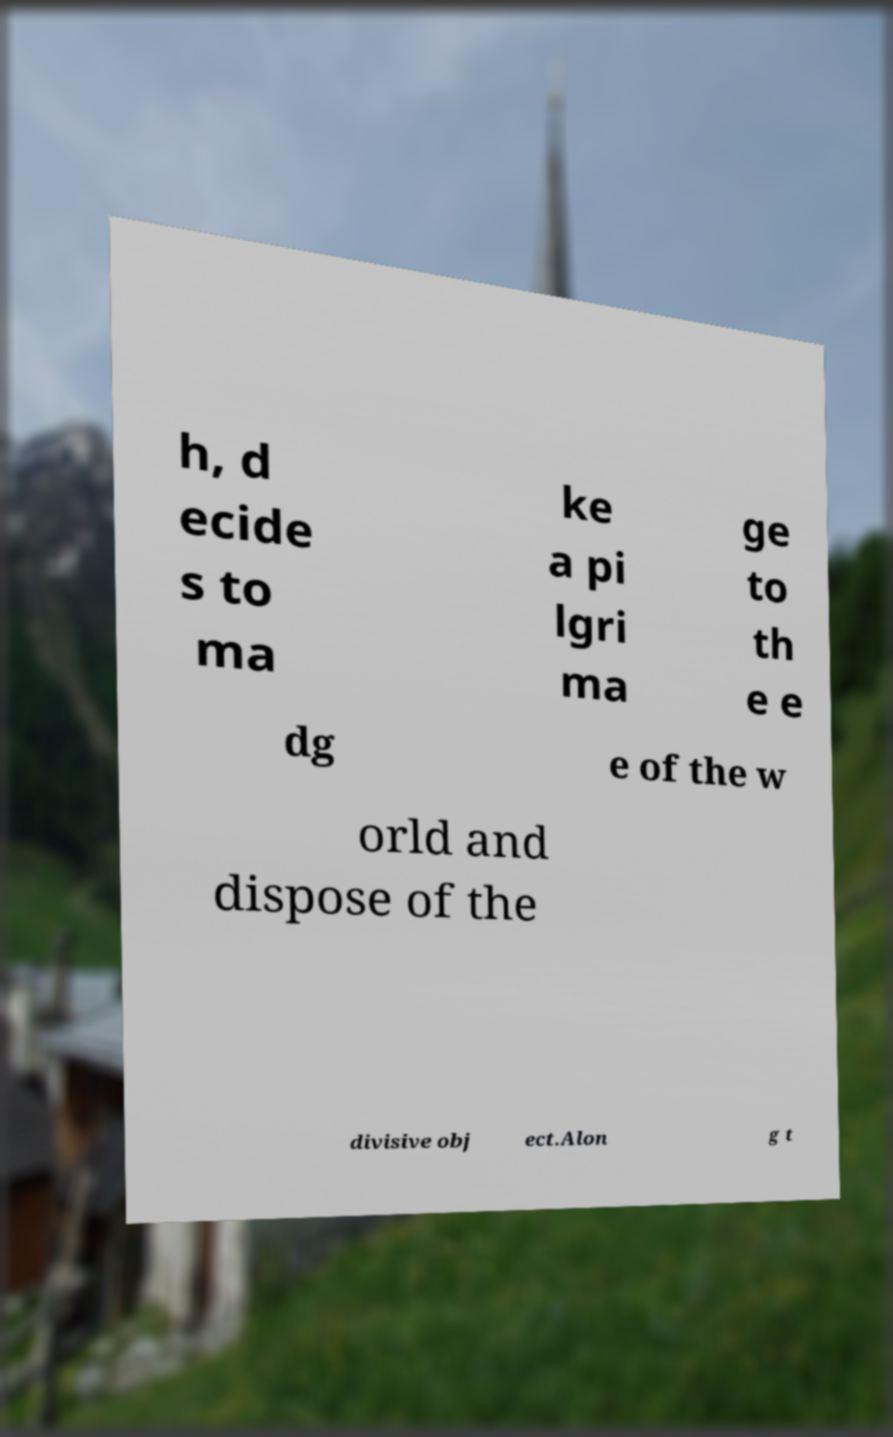I need the written content from this picture converted into text. Can you do that? h, d ecide s to ma ke a pi lgri ma ge to th e e dg e of the w orld and dispose of the divisive obj ect.Alon g t 